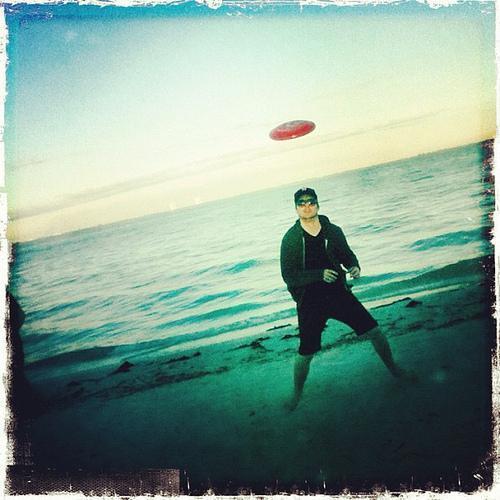How many people are in the picture?
Give a very brief answer. 1. 